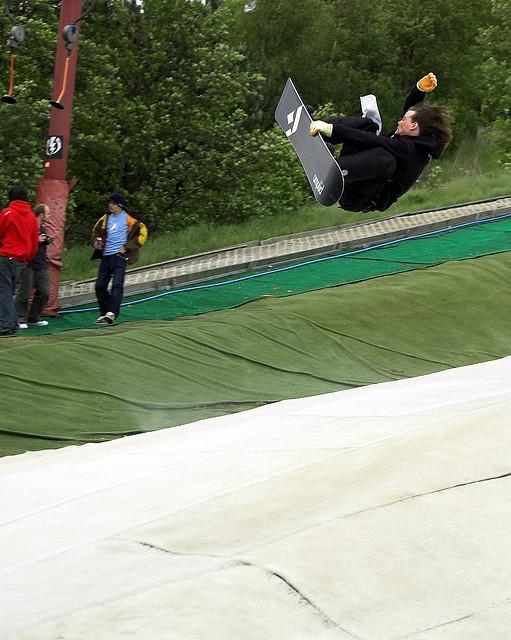What type of board is this? skateboard 